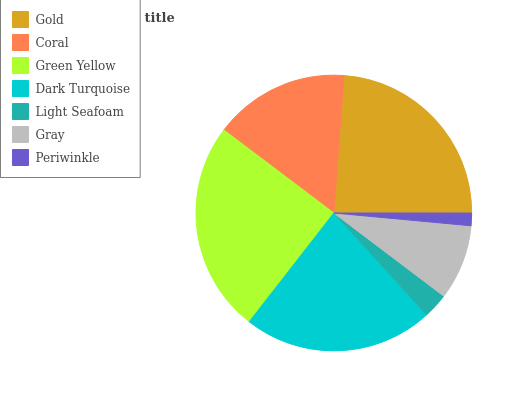Is Periwinkle the minimum?
Answer yes or no. Yes. Is Green Yellow the maximum?
Answer yes or no. Yes. Is Coral the minimum?
Answer yes or no. No. Is Coral the maximum?
Answer yes or no. No. Is Gold greater than Coral?
Answer yes or no. Yes. Is Coral less than Gold?
Answer yes or no. Yes. Is Coral greater than Gold?
Answer yes or no. No. Is Gold less than Coral?
Answer yes or no. No. Is Coral the high median?
Answer yes or no. Yes. Is Coral the low median?
Answer yes or no. Yes. Is Gray the high median?
Answer yes or no. No. Is Gray the low median?
Answer yes or no. No. 